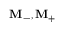<formula> <loc_0><loc_0><loc_500><loc_500>M _ { - } , M _ { + }</formula> 